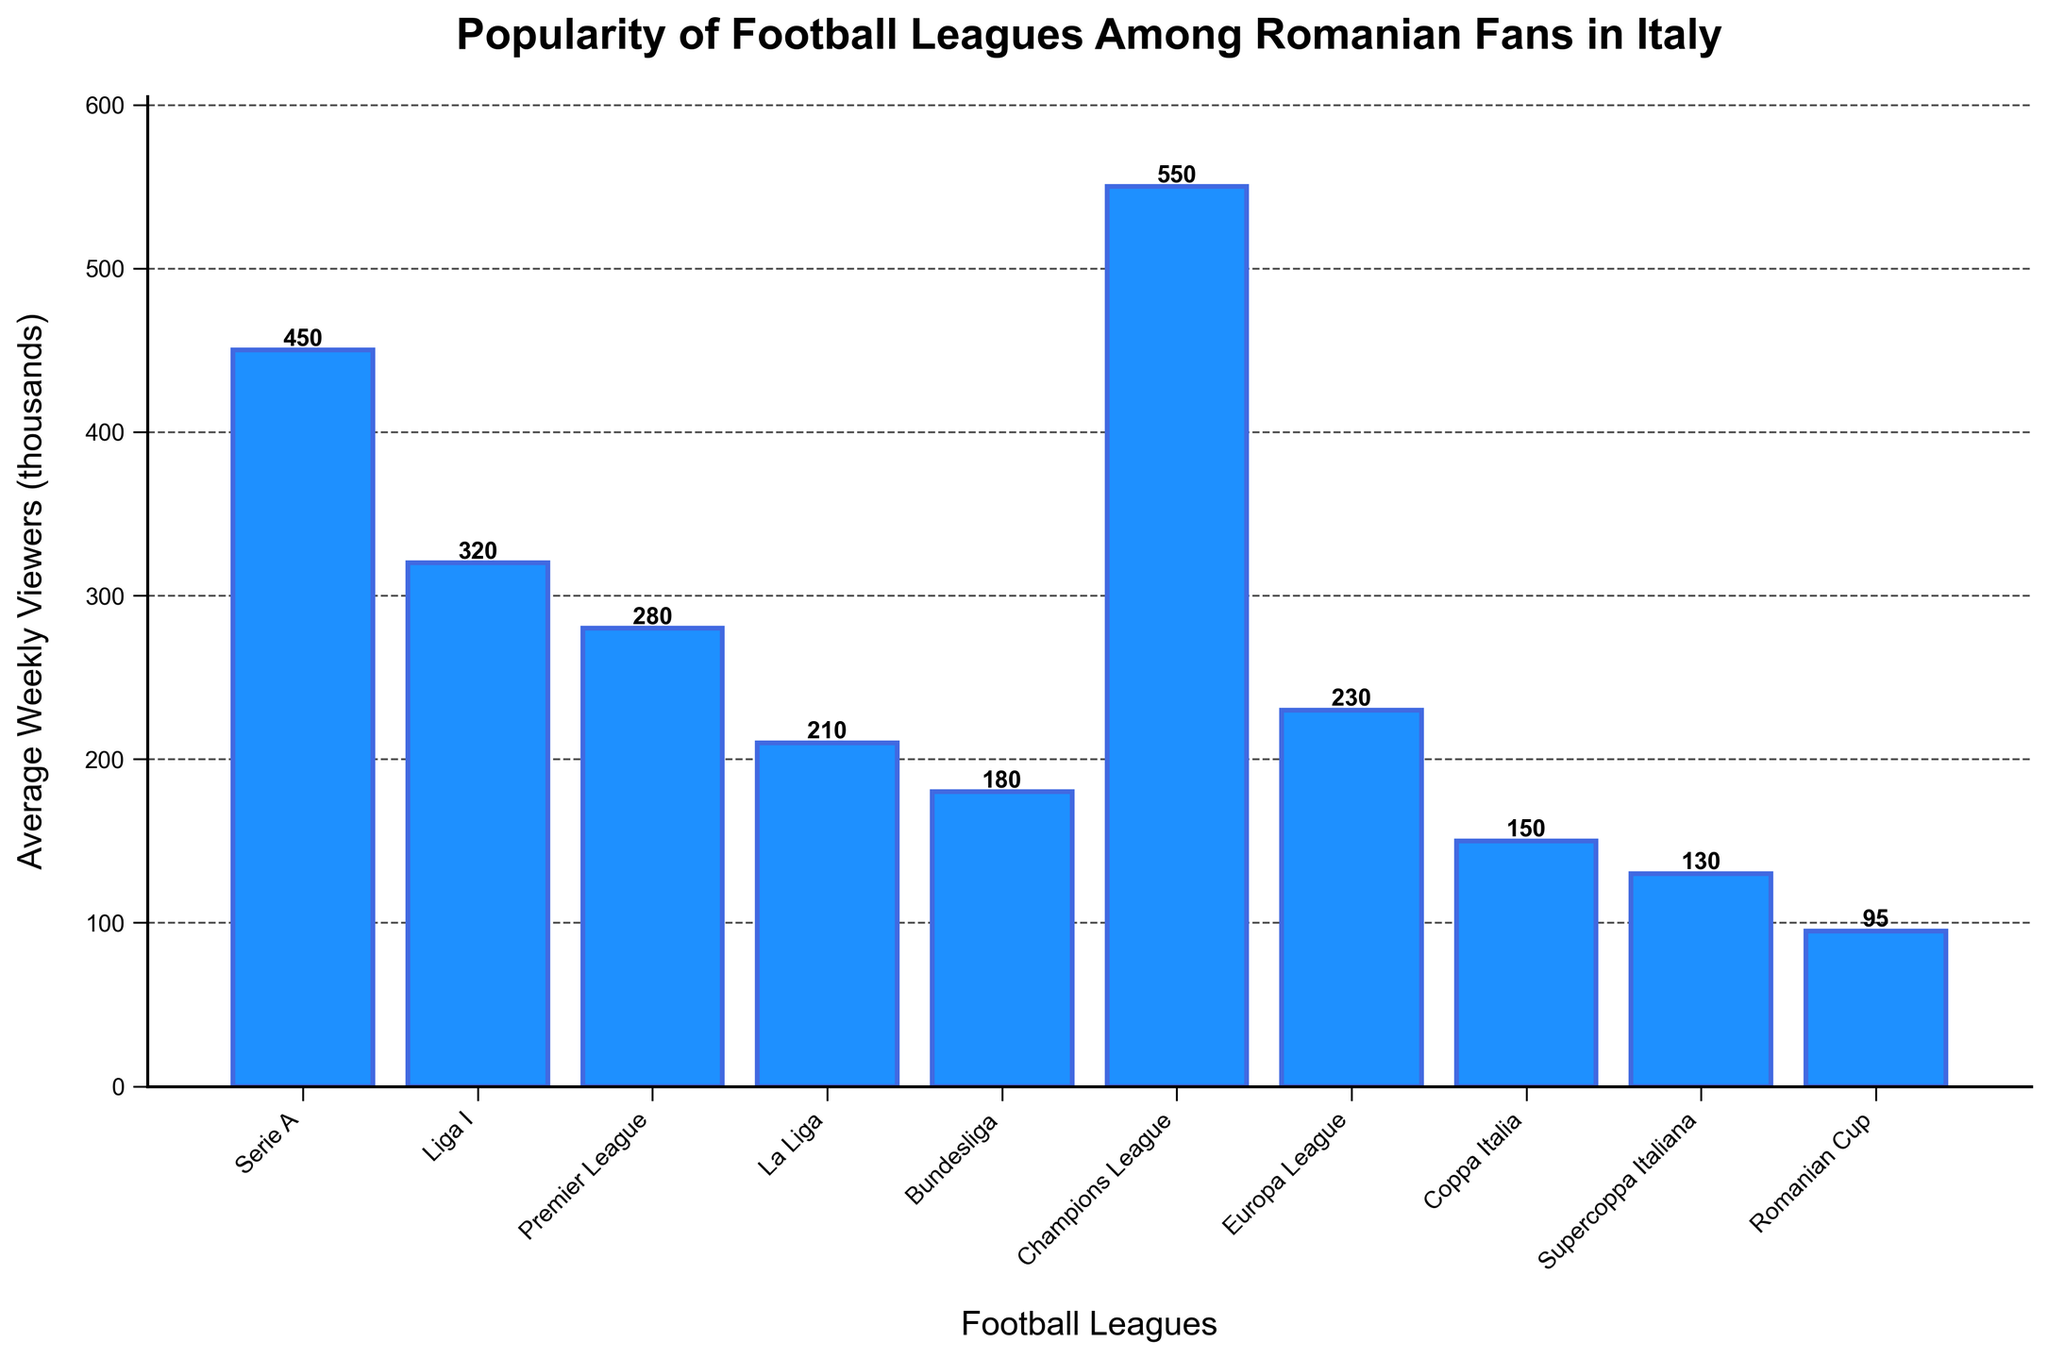Which football league has the highest average weekly viewership among Romanian fans in Italy? By examining the heights of the bars, we can see that the Champions League has the tallest bar, indicating the highest average weekly viewership.
Answer: Champions League Which league has a higher average weekly viewership, Serie A or Liga I? By comparing the heights of the bars, the bar for Serie A is higher than the bar for Liga I.
Answer: Serie A What is the total average weekly viewership of Serie A, Premier League, and La Liga combined? We add the average weekly viewers for each league: Serie A (450) + Premier League (280) + La Liga (210). The sum is 450 + 280 + 210 = 940.
Answer: 940 Which leagues have an average weekly viewership of less than 200,000? By observing the heights of the bars, we see that Bundesliga (180), Coppa Italia (150), Supercoppa Italiana (130), and Romanian Cup (95) each have average weekly viewerships less than 200,000.
Answer: Bundesliga, Coppa Italia, Supercoppa Italiana, Romanian Cup What is the difference between the average weekly viewership of the Champions League and the Romanian Cup? We subtract the Romanian Cup's viewership (95) from the Champions League's viewership (550). The result is 550 - 95 = 455.
Answer: 455 Among the leagues depicted, which one has the lowest average weekly viewership? By identifying the shortest bar, the Romanian Cup has the lowest average weekly viewership.
Answer: Romanian Cup How does the average weekly viewership of Premier League compare to that of Ligue 1? Ligue 1 is not included in the figure, so we can't compare.
Answer: Cannot compare Which two leagues have the closest average weekly viewership numbers? By closely examining the bar heights and their respective labels, Europa League (230) and La Liga (210) are the closest, with a difference of 20,000 viewers.
Answer: Europa League and La Liga Are there more viewers for Serie A or Coppa Italia? By comparing the heights of the bars, Serie A has a higher average weekly viewership than Coppa Italia.
Answer: Serie A If we combine the average weekly viewership of the Supercoppa Italiana and Bundesliga, is it higher than the Champions League viewership? Combine the Supercoppa Italiana (130) and Bundesliga (180): 130 + 180 = 310, which is less than the Champions League's 550.
Answer: No 